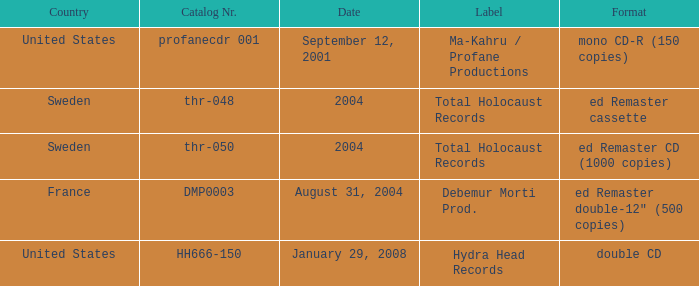What country is the Debemur Morti prod. label from? France. 